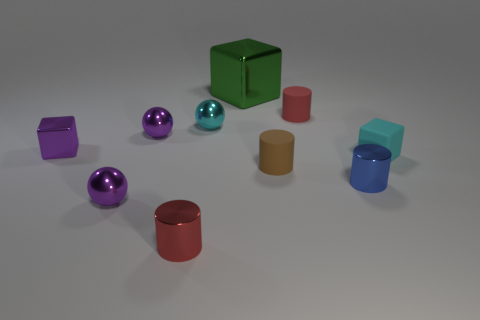Subtract all red cylinders. How many were subtracted if there are1red cylinders left? 1 Subtract 1 cylinders. How many cylinders are left? 3 Subtract all blocks. How many objects are left? 7 Add 3 tiny rubber blocks. How many tiny rubber blocks are left? 4 Add 6 brown things. How many brown things exist? 7 Subtract 0 brown blocks. How many objects are left? 10 Subtract all large metallic things. Subtract all big shiny cubes. How many objects are left? 8 